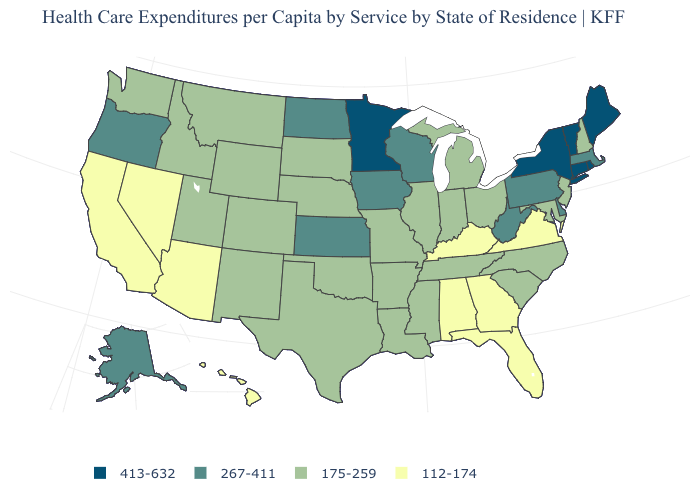What is the value of Connecticut?
Concise answer only. 413-632. Name the states that have a value in the range 267-411?
Write a very short answer. Alaska, Delaware, Iowa, Kansas, Massachusetts, North Dakota, Oregon, Pennsylvania, West Virginia, Wisconsin. Among the states that border Rhode Island , does Massachusetts have the lowest value?
Write a very short answer. Yes. What is the value of New Mexico?
Keep it brief. 175-259. What is the lowest value in the USA?
Write a very short answer. 112-174. Name the states that have a value in the range 175-259?
Quick response, please. Arkansas, Colorado, Idaho, Illinois, Indiana, Louisiana, Maryland, Michigan, Mississippi, Missouri, Montana, Nebraska, New Hampshire, New Jersey, New Mexico, North Carolina, Ohio, Oklahoma, South Carolina, South Dakota, Tennessee, Texas, Utah, Washington, Wyoming. Among the states that border Oklahoma , which have the highest value?
Quick response, please. Kansas. What is the highest value in the West ?
Concise answer only. 267-411. Name the states that have a value in the range 413-632?
Answer briefly. Connecticut, Maine, Minnesota, New York, Rhode Island, Vermont. What is the highest value in states that border West Virginia?
Short answer required. 267-411. What is the value of Mississippi?
Give a very brief answer. 175-259. What is the lowest value in states that border Vermont?
Quick response, please. 175-259. What is the value of Illinois?
Concise answer only. 175-259. Does Nebraska have a lower value than South Carolina?
Write a very short answer. No. What is the value of Ohio?
Quick response, please. 175-259. 